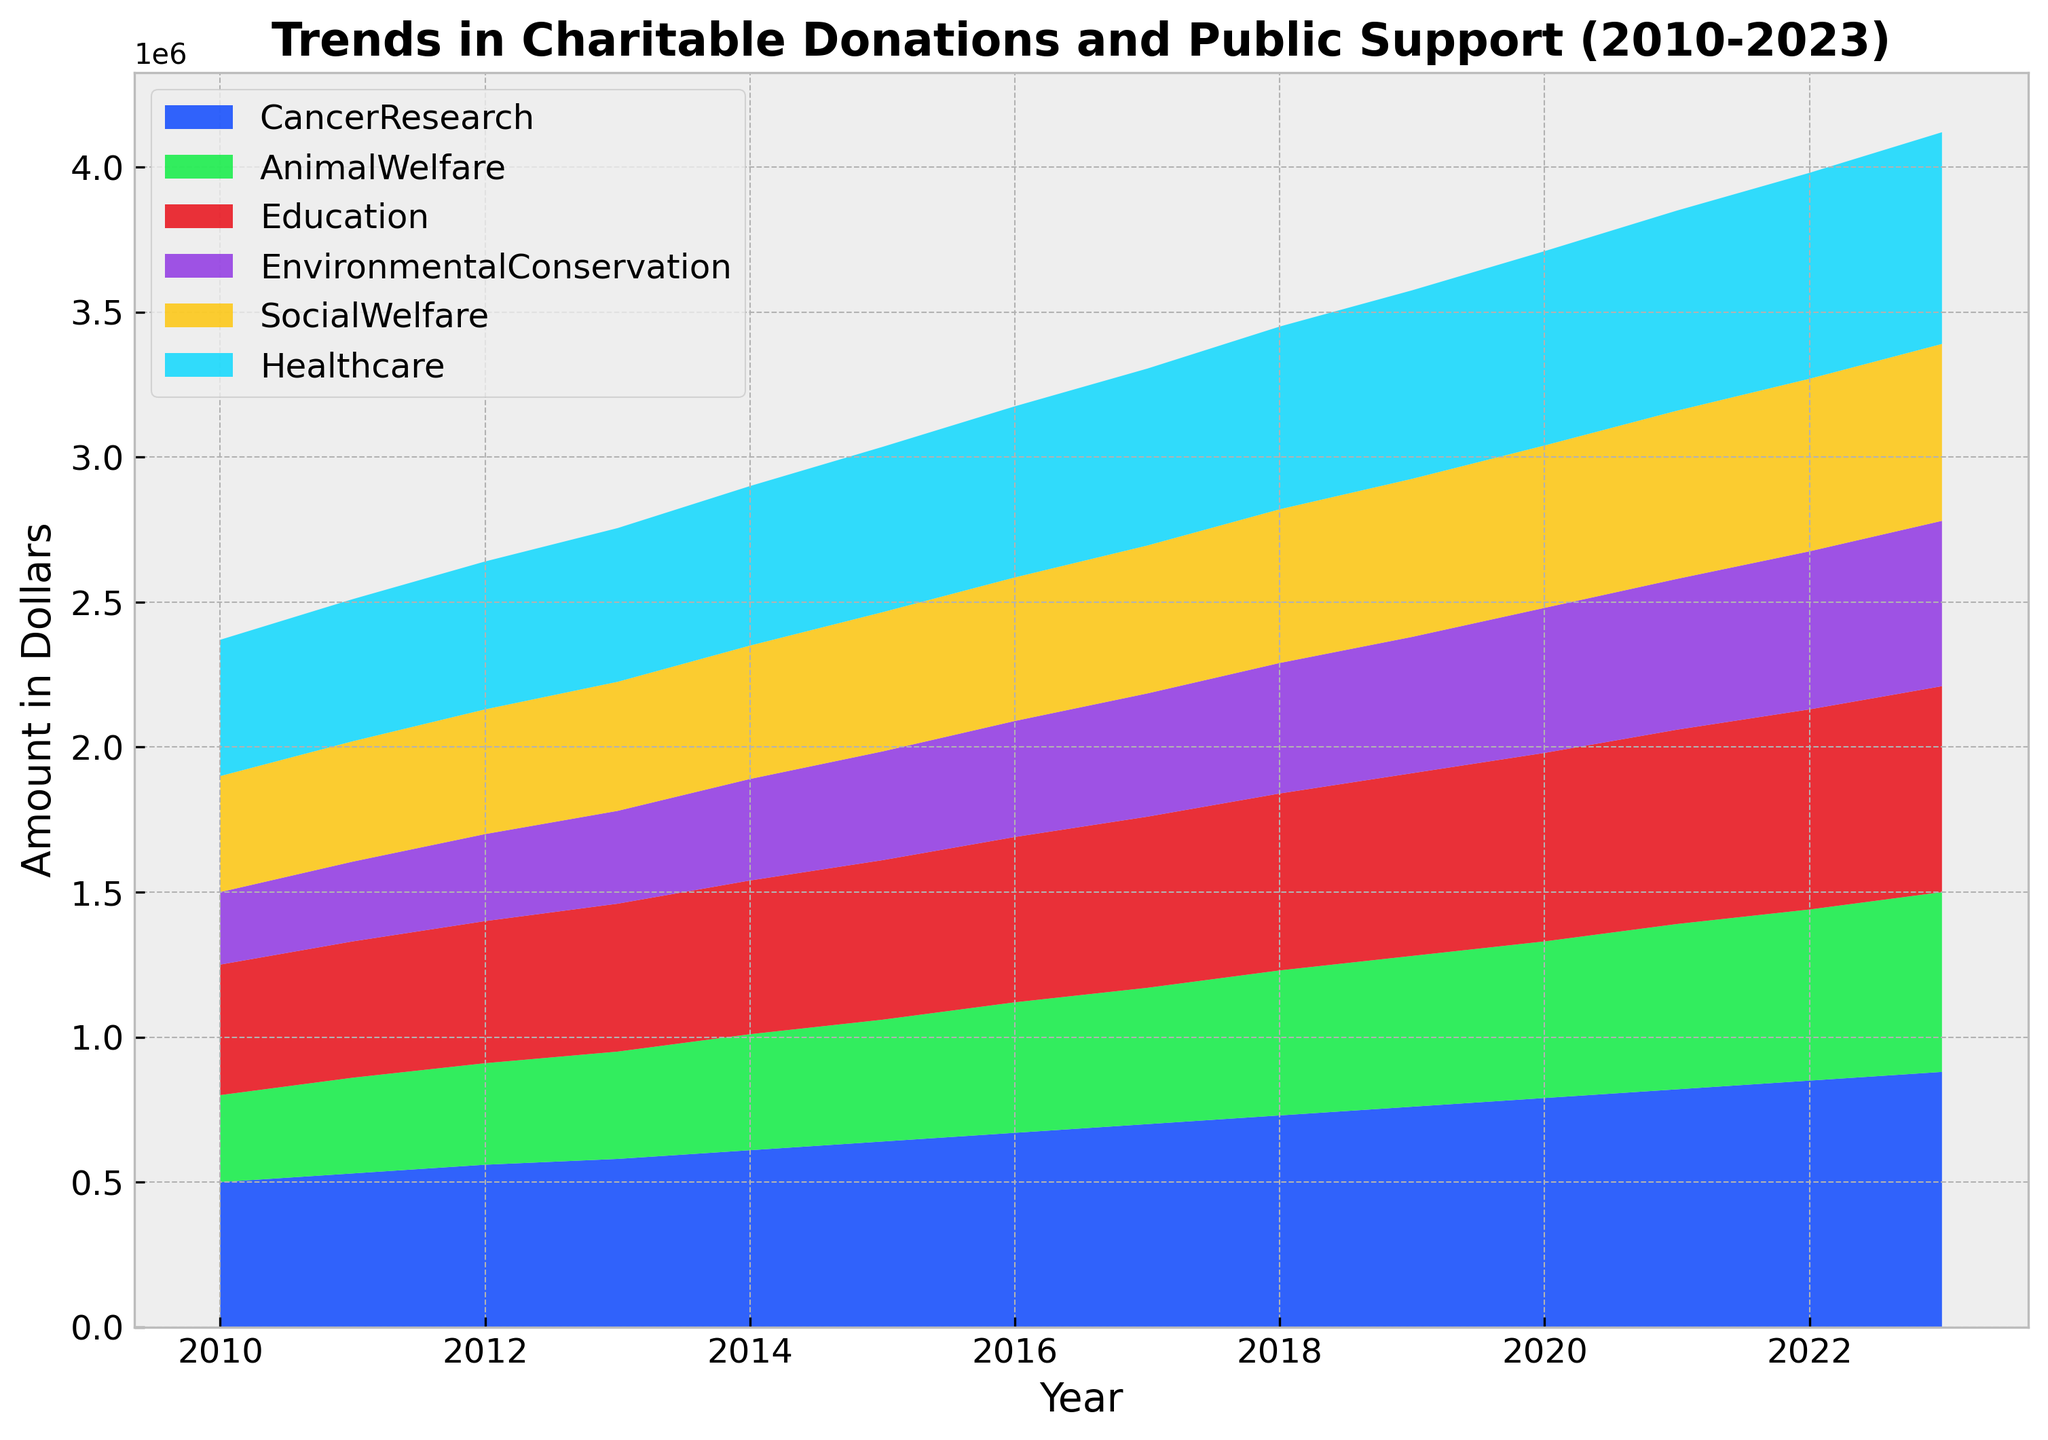How has support for Healthcare changed from 2010 to 2023? To find the change in support for Healthcare from 2010 to 2023, look at the values in the respective years. In 2010, the support was $470,000, and in 2023, it was $730,000. The change is $730,000 - $470,000.
Answer: $260,000 Which cause saw the highest increase in donations between 2010 and 2023? To determine the cause with the highest increase, calculate the difference between 2023 and 2010 for all causes. The differences are as follows: Cancer Research ($880,000 - $500,000 = $380,000), Animal Welfare ($620,000 - $300,000 = $320,000), Education ($710,000 - $450,000 = $260,000), Environmental Conservation ($570,000 - $250,000 = $320,000), Social Welfare ($610,000 - $400,000 = $210,000), and Healthcare ($730,000 - $470,000 = $260,000). The highest increase is for Cancer Research with $380,000.
Answer: Cancer Research In which year did Animal Welfare see the greatest annual increase in support? To find the greatest annual increase in support for Animal Welfare, compare year-to-year differences: (2011: $30,000, 2012: $20,000, 2013: $20,000, 2014: $30,000, 2015: $20,000, 2016: $30,000, 2017: $20,000, 2018: $30,000, 2019: $20,000, 2020: $20,000, 2021: $30,000, 2022: $20,000, 2023: $30,000). The greatest increase occurred in 2023.
Answer: 2023 What is the total combined support across all causes in 2023? To find the total combined support for all causes in 2023, sum the values: $880,000 (Cancer Research) + $620,000 (Animal Welfare) + $710,000 (Education) + $570,000 (Environmental Conservation) + $610,000 (Social Welfare) + $730,000 (Healthcare).
Answer: $4,120,000 Compare the growth trends of Education and Environmental Conservation from 2010 to 2023. Which one grew faster, and by how much? To compare growth trends, calculate the increase from 2010 to 2023 for both causes. Education: $710,000 - $450,000 = $260,000. Environmental Conservation: $570,000 - $250,000 = $320,000. Environmental Conservation grew faster by $320,000 - $260,000.
Answer: Environmental Conservation by $60,000 